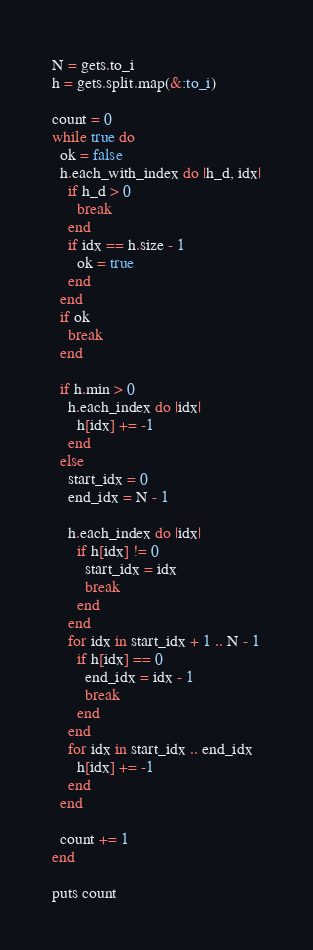Convert code to text. <code><loc_0><loc_0><loc_500><loc_500><_Ruby_>N = gets.to_i
h = gets.split.map(&:to_i)

count = 0
while true do
  ok = false
  h.each_with_index do |h_d, idx|
    if h_d > 0
      break
    end
    if idx == h.size - 1
      ok = true
    end
  end
  if ok
    break
  end

  if h.min > 0
    h.each_index do |idx|
      h[idx] += -1
    end
  else
    start_idx = 0
    end_idx = N - 1

    h.each_index do |idx|
      if h[idx] != 0
        start_idx = idx
        break
      end
    end
    for idx in start_idx + 1 .. N - 1
      if h[idx] == 0
        end_idx = idx - 1
        break
      end
    end
    for idx in start_idx .. end_idx
      h[idx] += -1
    end
  end

  count += 1
end

puts count</code> 